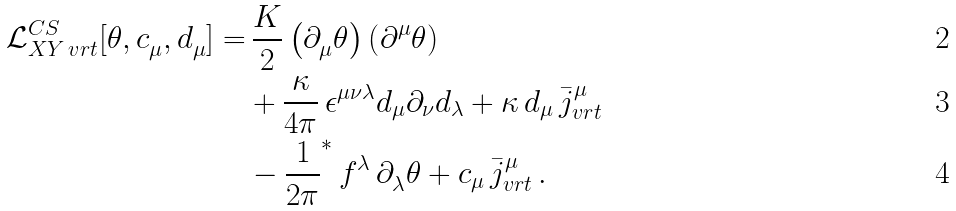Convert formula to latex. <formula><loc_0><loc_0><loc_500><loc_500>\mathcal { L } ^ { C S } _ { X Y \, v r t } [ \theta , c ^ { \ } _ { \mu } , d ^ { \ } _ { \mu } ] = & \, \frac { K } { 2 } \left ( \partial ^ { \ } _ { \mu } \theta \right ) \left ( \partial ^ { \mu } \theta \right ) \\ & + \frac { \kappa } { 4 \pi } \, \epsilon ^ { \mu \nu \lambda } d _ { \mu } \partial _ { \nu } d _ { \lambda } + \kappa \, d _ { \mu } \, \bar { j } ^ { \mu } _ { v r t } \\ & - \frac { 1 } { 2 \pi } ^ { * } \, f ^ { \lambda } \, \partial ^ { \ } _ { \lambda } \theta + c _ { \mu } \, \bar { j } ^ { \mu } _ { v r t } \, .</formula> 